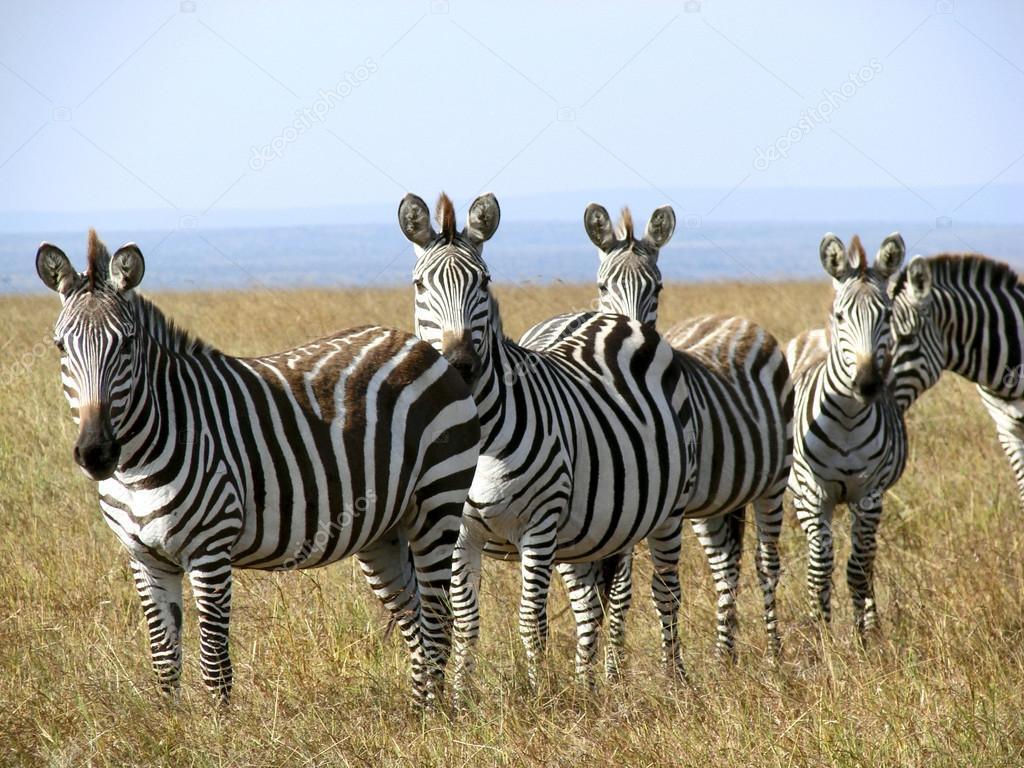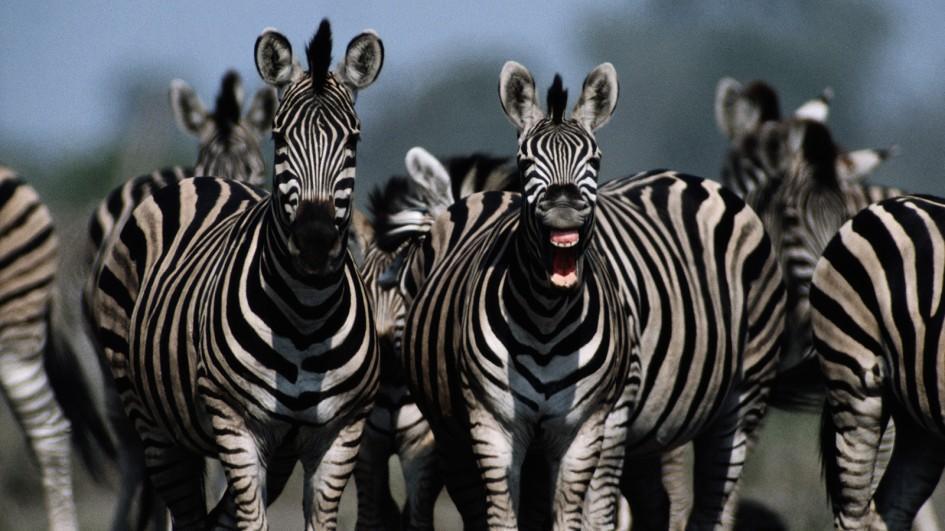The first image is the image on the left, the second image is the image on the right. Considering the images on both sides, is "In one image there are exactly three zebras present and the other shows more than three." valid? Answer yes or no. No. The first image is the image on the left, the second image is the image on the right. For the images displayed, is the sentence "The left image contains at least three times as many zebras as the right image." factually correct? Answer yes or no. No. 